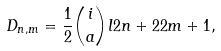<formula> <loc_0><loc_0><loc_500><loc_500>D _ { n , m } = \frac { 1 } { 2 } \binom { i } { a } l { 2 n + 2 } { 2 m + 1 } ,</formula> 